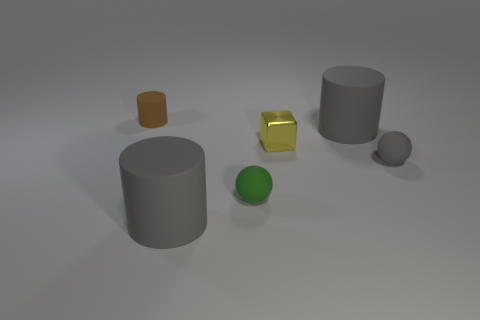Subtract all tiny cylinders. How many cylinders are left? 2 Add 1 brown rubber things. How many objects exist? 7 Subtract all gray cylinders. How many cylinders are left? 1 Add 1 green objects. How many green objects are left? 2 Add 6 brown shiny blocks. How many brown shiny blocks exist? 6 Subtract 1 brown cylinders. How many objects are left? 5 Subtract all cubes. How many objects are left? 5 Subtract all purple cylinders. Subtract all gray spheres. How many cylinders are left? 3 Subtract all green blocks. How many brown spheres are left? 0 Subtract all shiny cylinders. Subtract all tiny green rubber objects. How many objects are left? 5 